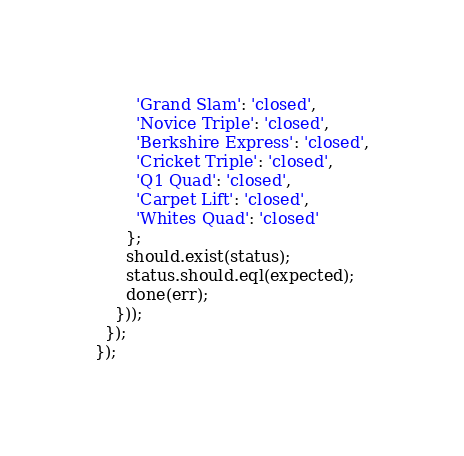Convert code to text. <code><loc_0><loc_0><loc_500><loc_500><_JavaScript_>        'Grand Slam': 'closed',
        'Novice Triple': 'closed',
        'Berkshire Express': 'closed',
        'Cricket Triple': 'closed',
        'Q1 Quad': 'closed',
        'Carpet Lift': 'closed',
        'Whites Quad': 'closed'
      };
      should.exist(status);
      status.should.eql(expected);
      done(err);
    }));
  });
});
</code> 